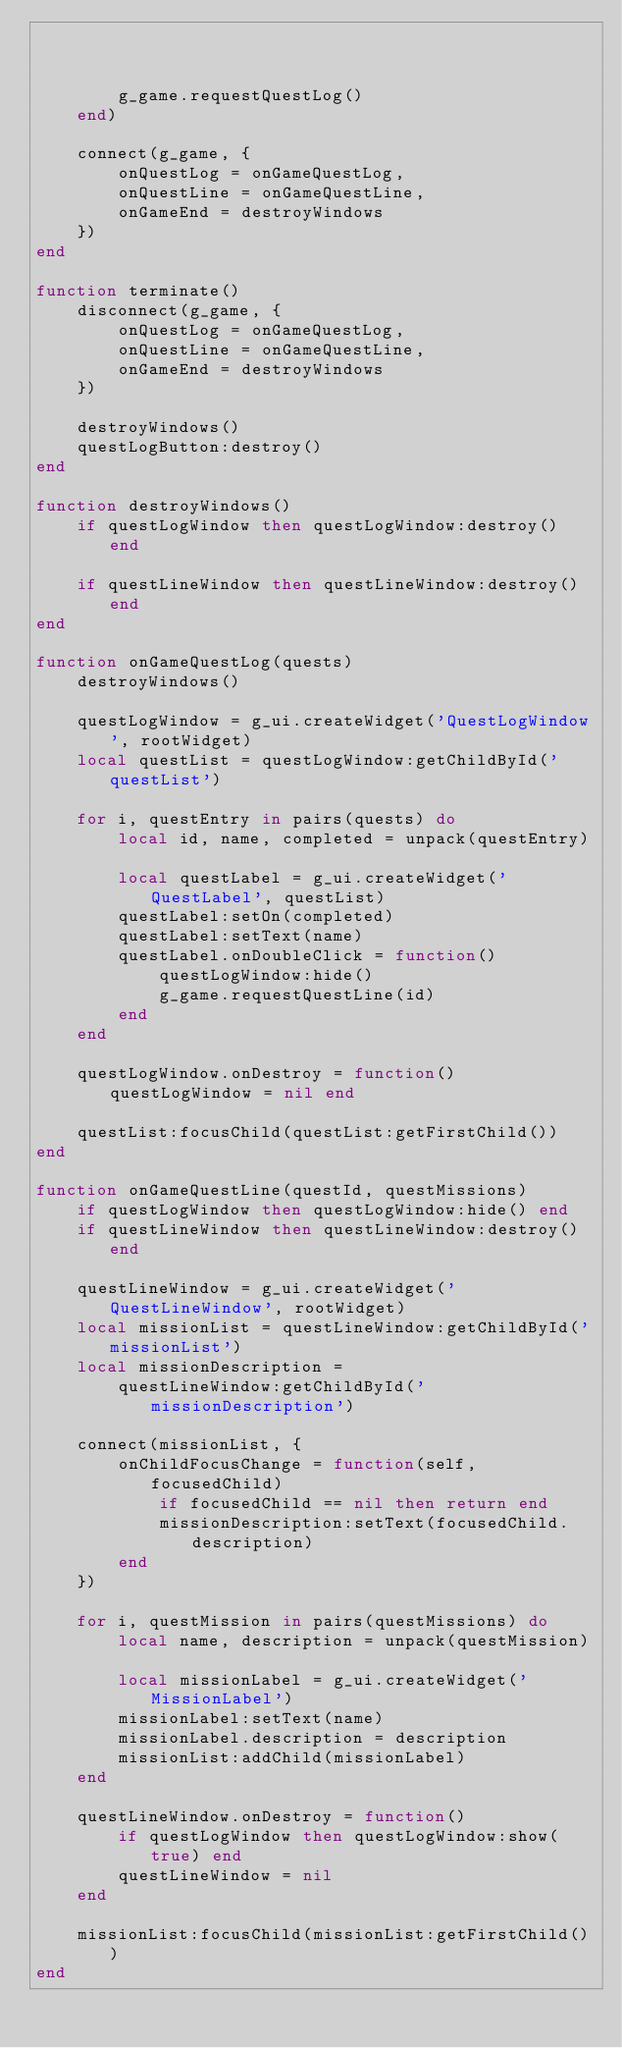Convert code to text. <code><loc_0><loc_0><loc_500><loc_500><_Lua_>                                                              function()
        g_game.requestQuestLog()
    end)

    connect(g_game, {
        onQuestLog = onGameQuestLog,
        onQuestLine = onGameQuestLine,
        onGameEnd = destroyWindows
    })
end

function terminate()
    disconnect(g_game, {
        onQuestLog = onGameQuestLog,
        onQuestLine = onGameQuestLine,
        onGameEnd = destroyWindows
    })

    destroyWindows()
    questLogButton:destroy()
end

function destroyWindows()
    if questLogWindow then questLogWindow:destroy() end

    if questLineWindow then questLineWindow:destroy() end
end

function onGameQuestLog(quests)
    destroyWindows()

    questLogWindow = g_ui.createWidget('QuestLogWindow', rootWidget)
    local questList = questLogWindow:getChildById('questList')

    for i, questEntry in pairs(quests) do
        local id, name, completed = unpack(questEntry)

        local questLabel = g_ui.createWidget('QuestLabel', questList)
        questLabel:setOn(completed)
        questLabel:setText(name)
        questLabel.onDoubleClick = function()
            questLogWindow:hide()
            g_game.requestQuestLine(id)
        end
    end

    questLogWindow.onDestroy = function() questLogWindow = nil end

    questList:focusChild(questList:getFirstChild())
end

function onGameQuestLine(questId, questMissions)
    if questLogWindow then questLogWindow:hide() end
    if questLineWindow then questLineWindow:destroy() end

    questLineWindow = g_ui.createWidget('QuestLineWindow', rootWidget)
    local missionList = questLineWindow:getChildById('missionList')
    local missionDescription =
        questLineWindow:getChildById('missionDescription')

    connect(missionList, {
        onChildFocusChange = function(self, focusedChild)
            if focusedChild == nil then return end
            missionDescription:setText(focusedChild.description)
        end
    })

    for i, questMission in pairs(questMissions) do
        local name, description = unpack(questMission)

        local missionLabel = g_ui.createWidget('MissionLabel')
        missionLabel:setText(name)
        missionLabel.description = description
        missionList:addChild(missionLabel)
    end

    questLineWindow.onDestroy = function()
        if questLogWindow then questLogWindow:show(true) end
        questLineWindow = nil
    end

    missionList:focusChild(missionList:getFirstChild())
end
</code> 